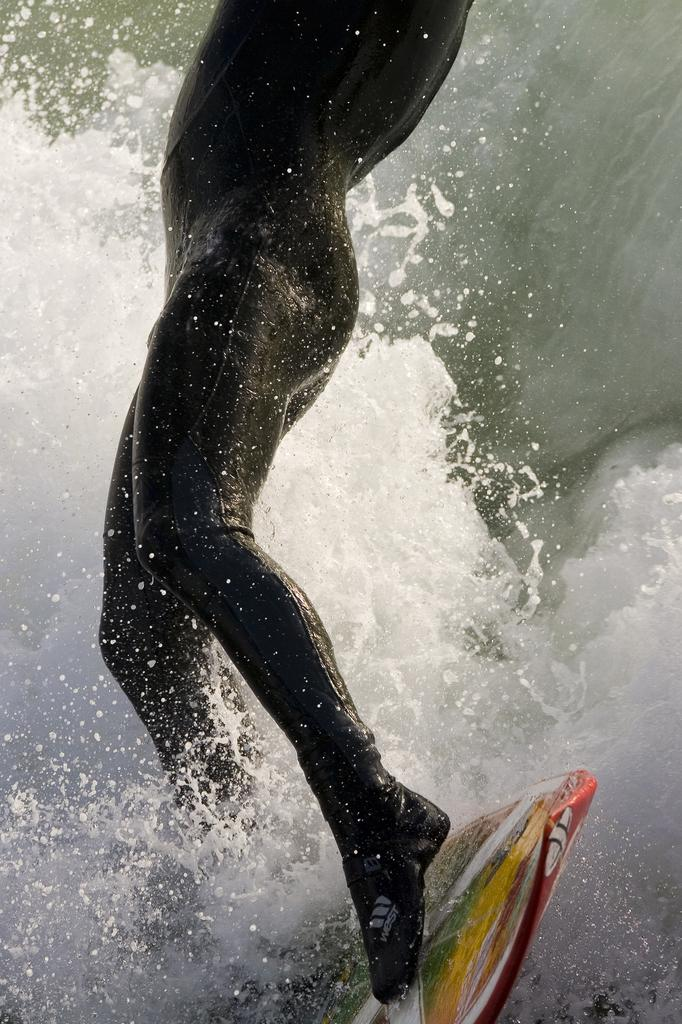What is the main subject of the image? There is a person in the image. What activity is the person engaged in? The person is surfing in the water. What tool or equipment is the person using for surfing? The person is using a surfboard. What type of net can be seen in the image? There is no net present in the image; it features a person surfing on a surfboard. 